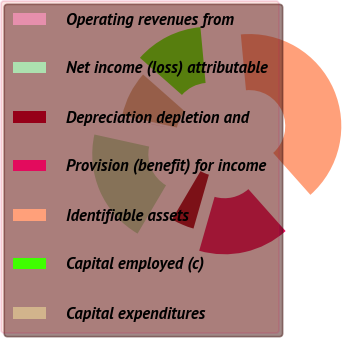Convert chart to OTSL. <chart><loc_0><loc_0><loc_500><loc_500><pie_chart><fcel>Operating revenues from<fcel>Net income (loss) attributable<fcel>Depreciation depletion and<fcel>Provision (benefit) for income<fcel>Identifiable assets<fcel>Capital employed (c)<fcel>Capital expenditures<nl><fcel>0.05%<fcel>19.98%<fcel>4.04%<fcel>15.99%<fcel>39.91%<fcel>12.01%<fcel>8.02%<nl></chart> 